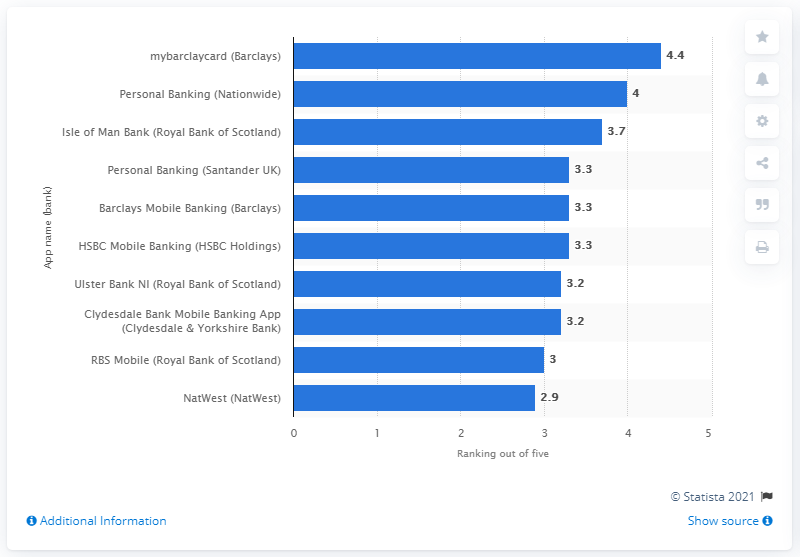List a handful of essential elements in this visual. The user rating of mybarclaycard was 4.4... 